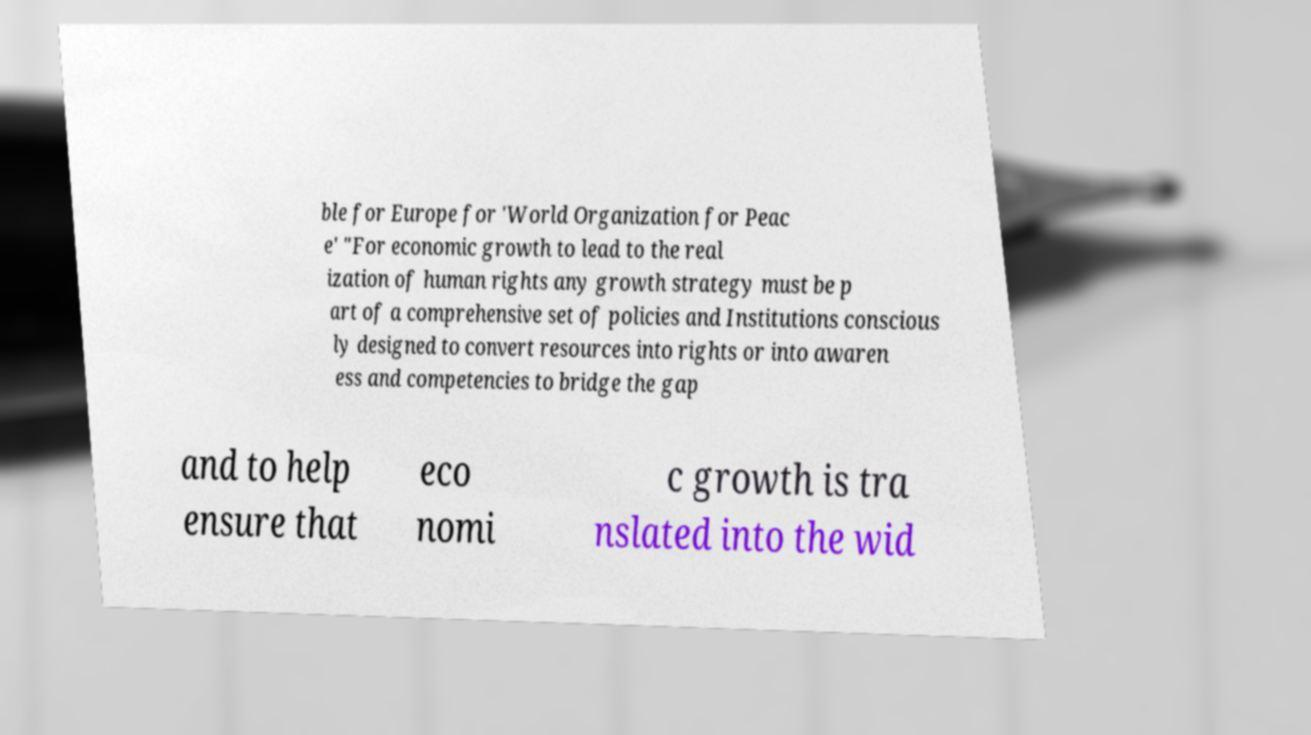Can you read and provide the text displayed in the image?This photo seems to have some interesting text. Can you extract and type it out for me? ble for Europe for 'World Organization for Peac e' "For economic growth to lead to the real ization of human rights any growth strategy must be p art of a comprehensive set of policies and Institutions conscious ly designed to convert resources into rights or into awaren ess and competencies to bridge the gap and to help ensure that eco nomi c growth is tra nslated into the wid 